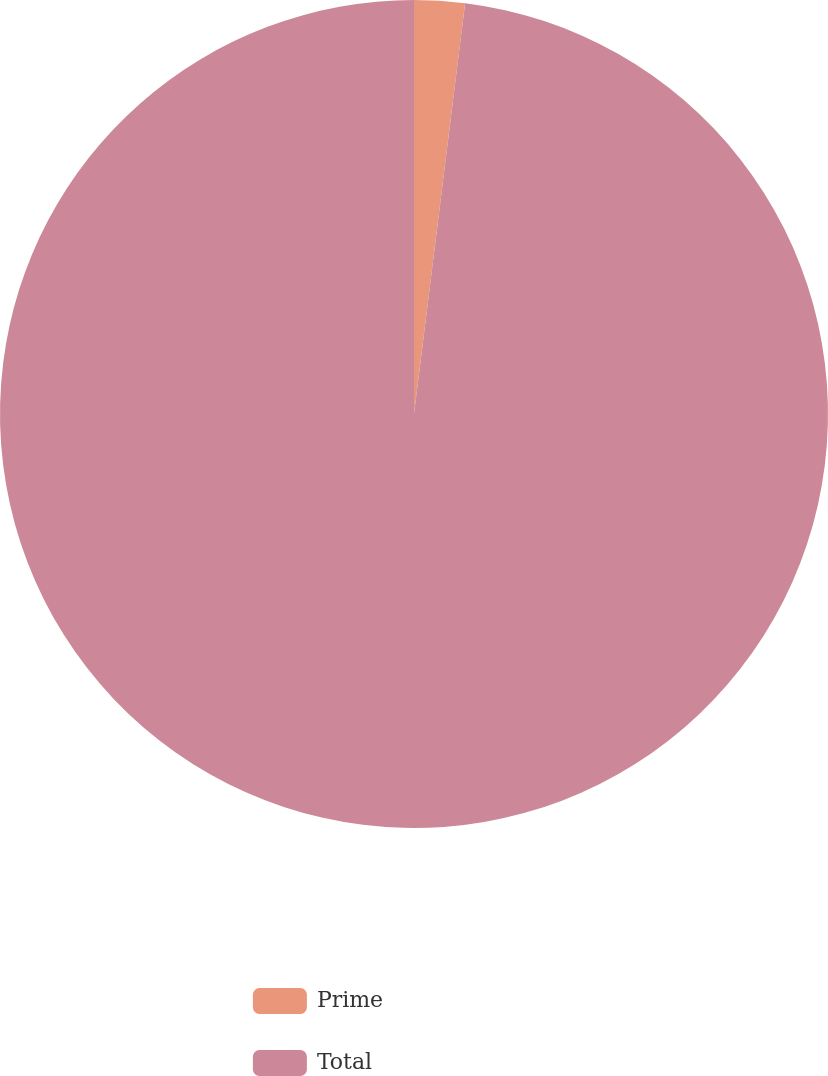<chart> <loc_0><loc_0><loc_500><loc_500><pie_chart><fcel>Prime<fcel>Total<nl><fcel>1.97%<fcel>98.03%<nl></chart> 